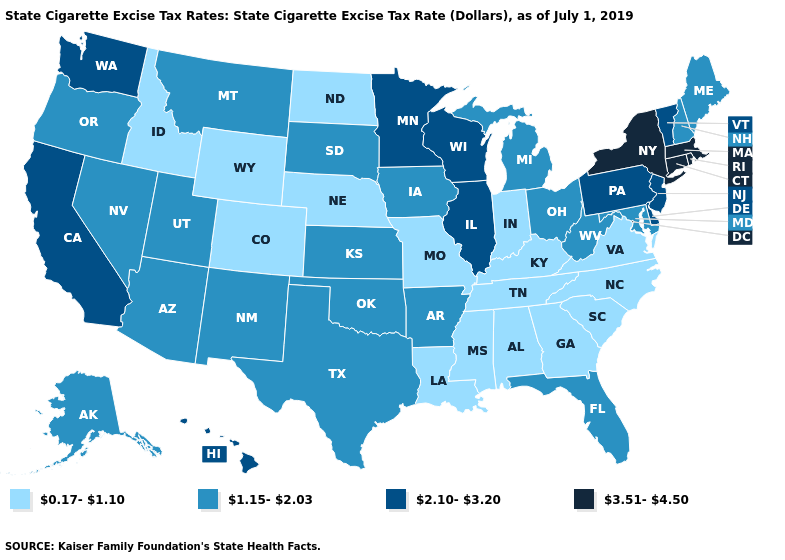What is the value of Oregon?
Write a very short answer. 1.15-2.03. What is the value of Vermont?
Be succinct. 2.10-3.20. What is the value of Massachusetts?
Give a very brief answer. 3.51-4.50. Does Delaware have the same value as Pennsylvania?
Keep it brief. Yes. Which states have the highest value in the USA?
Answer briefly. Connecticut, Massachusetts, New York, Rhode Island. Which states have the lowest value in the USA?
Quick response, please. Alabama, Colorado, Georgia, Idaho, Indiana, Kentucky, Louisiana, Mississippi, Missouri, Nebraska, North Carolina, North Dakota, South Carolina, Tennessee, Virginia, Wyoming. Is the legend a continuous bar?
Quick response, please. No. Does the map have missing data?
Concise answer only. No. What is the value of Iowa?
Short answer required. 1.15-2.03. Does Louisiana have the same value as North Carolina?
Short answer required. Yes. Name the states that have a value in the range 3.51-4.50?
Write a very short answer. Connecticut, Massachusetts, New York, Rhode Island. Name the states that have a value in the range 2.10-3.20?
Keep it brief. California, Delaware, Hawaii, Illinois, Minnesota, New Jersey, Pennsylvania, Vermont, Washington, Wisconsin. Which states hav the highest value in the Northeast?
Concise answer only. Connecticut, Massachusetts, New York, Rhode Island. What is the value of Missouri?
Keep it brief. 0.17-1.10. What is the value of Hawaii?
Short answer required. 2.10-3.20. 